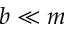<formula> <loc_0><loc_0><loc_500><loc_500>b \ll m</formula> 